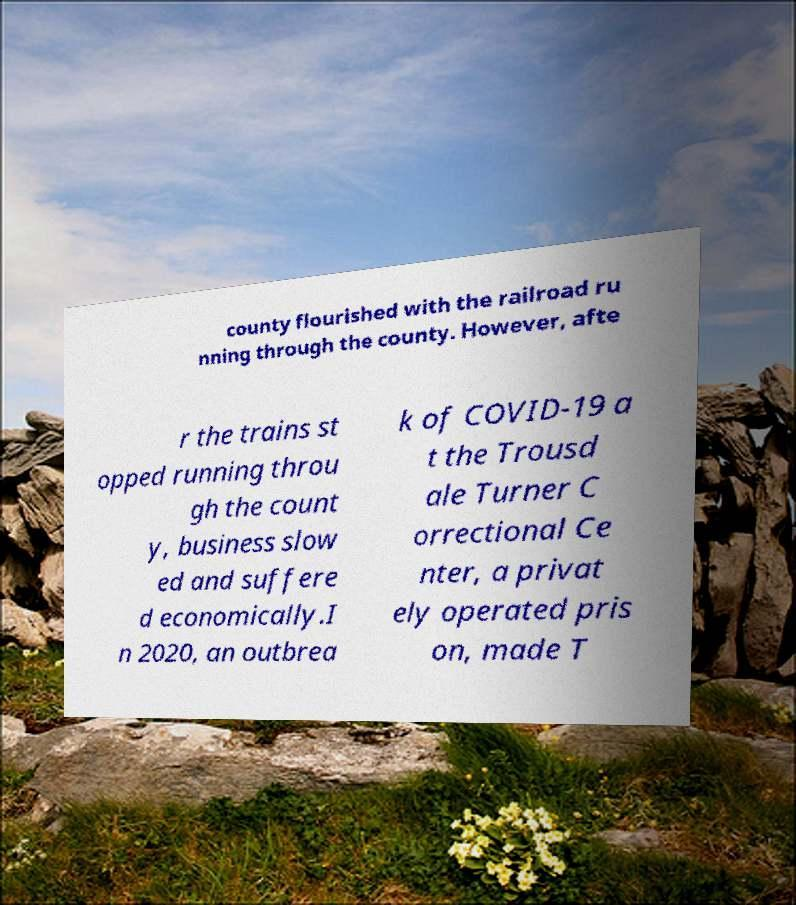Can you read and provide the text displayed in the image?This photo seems to have some interesting text. Can you extract and type it out for me? county flourished with the railroad ru nning through the county. However, afte r the trains st opped running throu gh the count y, business slow ed and suffere d economically.I n 2020, an outbrea k of COVID-19 a t the Trousd ale Turner C orrectional Ce nter, a privat ely operated pris on, made T 